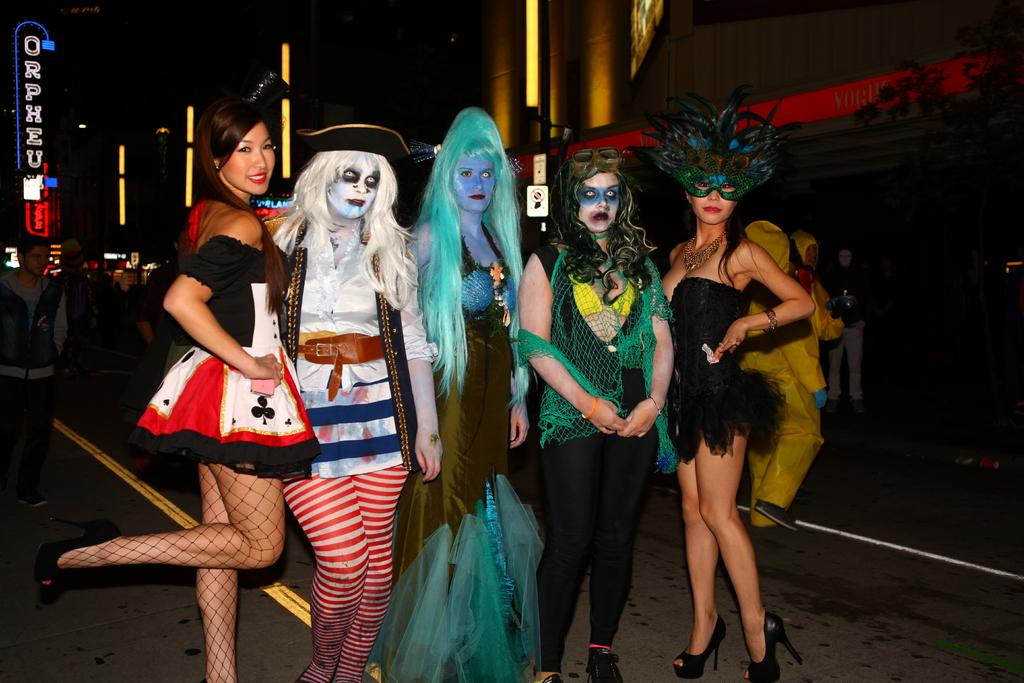How many ladies are in the image wearing different costumes? There are five ladies in different costumes in the image. What can be seen in the background of the image? Many people and buildings are visible in the background of the image. What objects are present in the image that might indicate a specific location or event? Name boards are present in the image. What else can be seen in the image that might provide context or atmosphere? Lights are visible in the image. Can you see any fog in the image? There is no fog visible in the image. What type of veil is being worn by the ladies in the image? The ladies in the image are not wearing veils; they are wearing different costumes. 